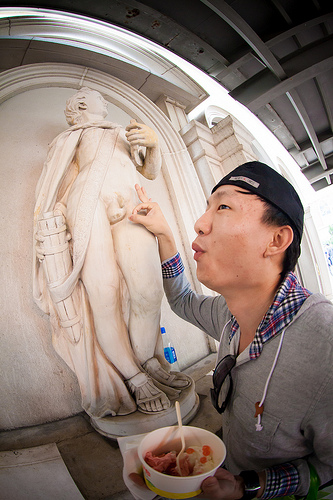<image>
Is the sun glasses under the monkey cap? Yes. The sun glasses is positioned underneath the monkey cap, with the monkey cap above it in the vertical space. 